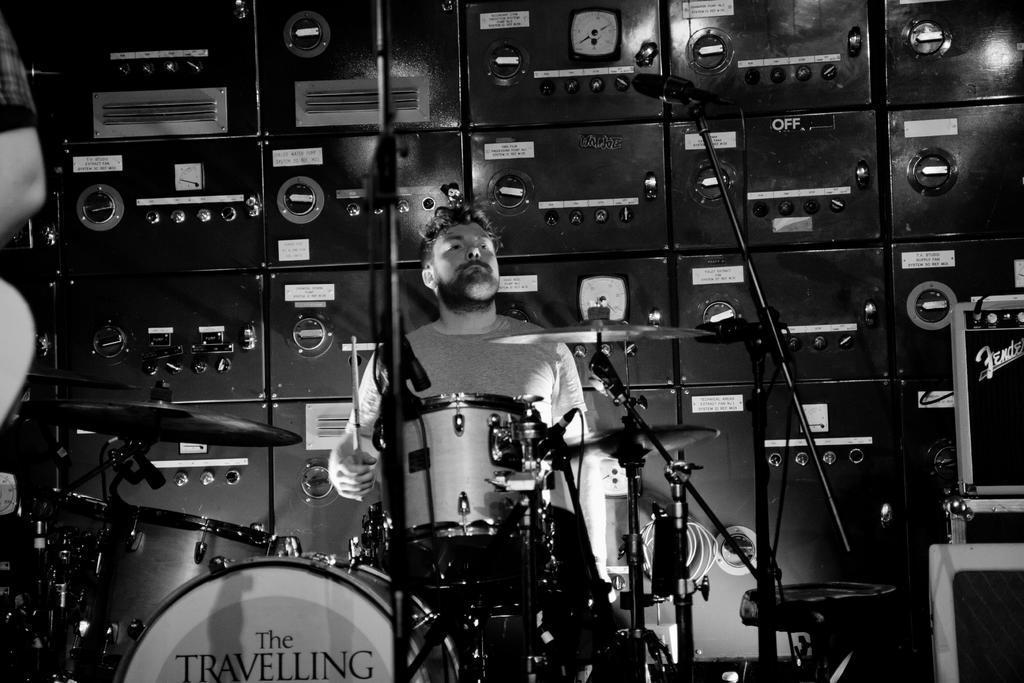How would you summarize this image in a sentence or two? In the image we can see there is a man sitting on the chair and there is a drum set. Behind there is a speedometer and there are boxes kept on the floor. The image is in black and white colour and its written ¨The Travelling¨ on the drum. 